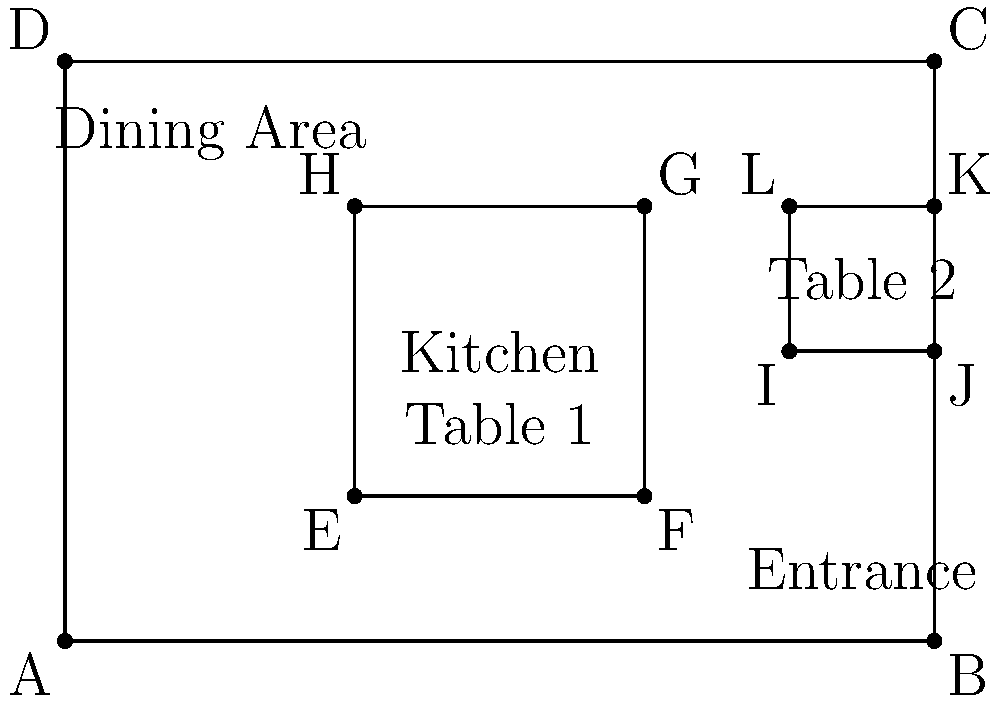As a regular customer at your favorite restaurant, you've become curious about its layout. The owner has shown you a simplified floor plan. Which two shapes in the restaurant's layout are congruent, and how can you prove it? To determine which shapes are congruent in the restaurant floor plan, we need to compare the quadrilaterals in the diagram:

1. The main dining area (ABCD)
2. The kitchen area (EFGH)
3. Table 2 area (IJKL)

To prove congruence, we need to show that two shapes have the same size and shape. We can do this by demonstrating that they have:
a) Four equal sides (if they're rectangles)
b) Four equal angles (all 90° for rectangles)

Let's analyze each shape:

1. ABCD: This is the largest rectangle, representing the entire restaurant.
2. EFGH: This is a smaller rectangle inside ABCD, representing the kitchen.
3. IJKL: This is the smallest rectangle, representing Table 2.

Comparing EFGH and IJKL:

a) Side lengths:
   EF = 2 units, FG = 2 units
   IJ = 1 unit, JK = 1 unit

b) Angles:
   Both EFGH and IJKL have four 90° angles.

While both shapes are rectangles with equal angles, their side lengths are different. Therefore, EFGH and IJKL are not congruent.

The only congruent shapes in this floor plan are the individual tables:
- Table 1 (not labeled, but visible inside EFGH)
- Table 2 (IJKL)

These tables appear to have the same dimensions and shape, making them congruent.
Answer: Table 1 and Table 2 